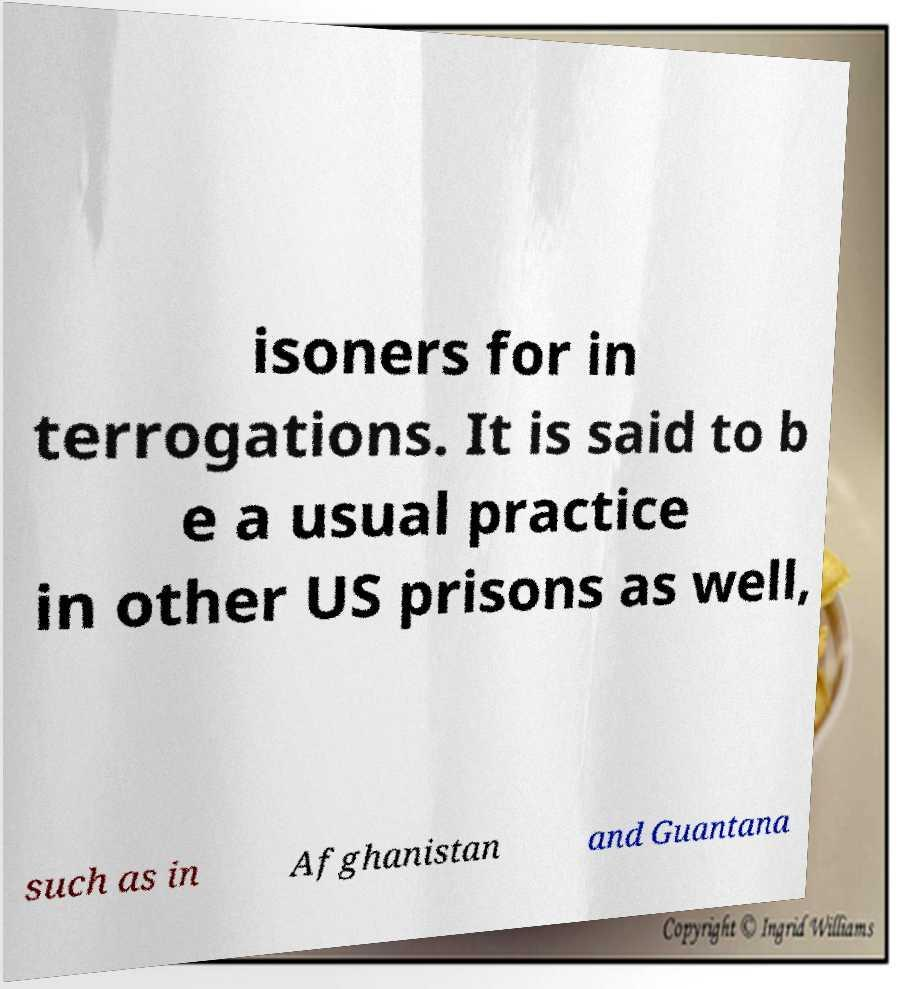Can you accurately transcribe the text from the provided image for me? isoners for in terrogations. It is said to b e a usual practice in other US prisons as well, such as in Afghanistan and Guantana 